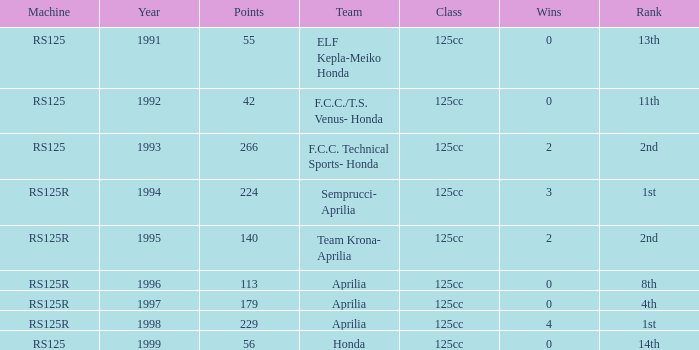Which class had a machine of RS125R, points over 113, and a rank of 4th? 125cc. 